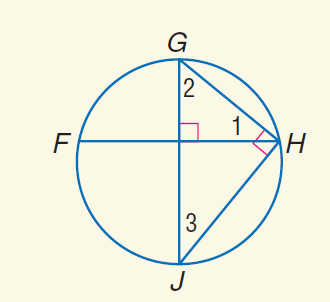Answer the mathemtical geometry problem and directly provide the correct option letter.
Question: m \widehat J H = 114. Find m \angle 3.
Choices: A: 33 B: 43 C: 57 D: 67 A 